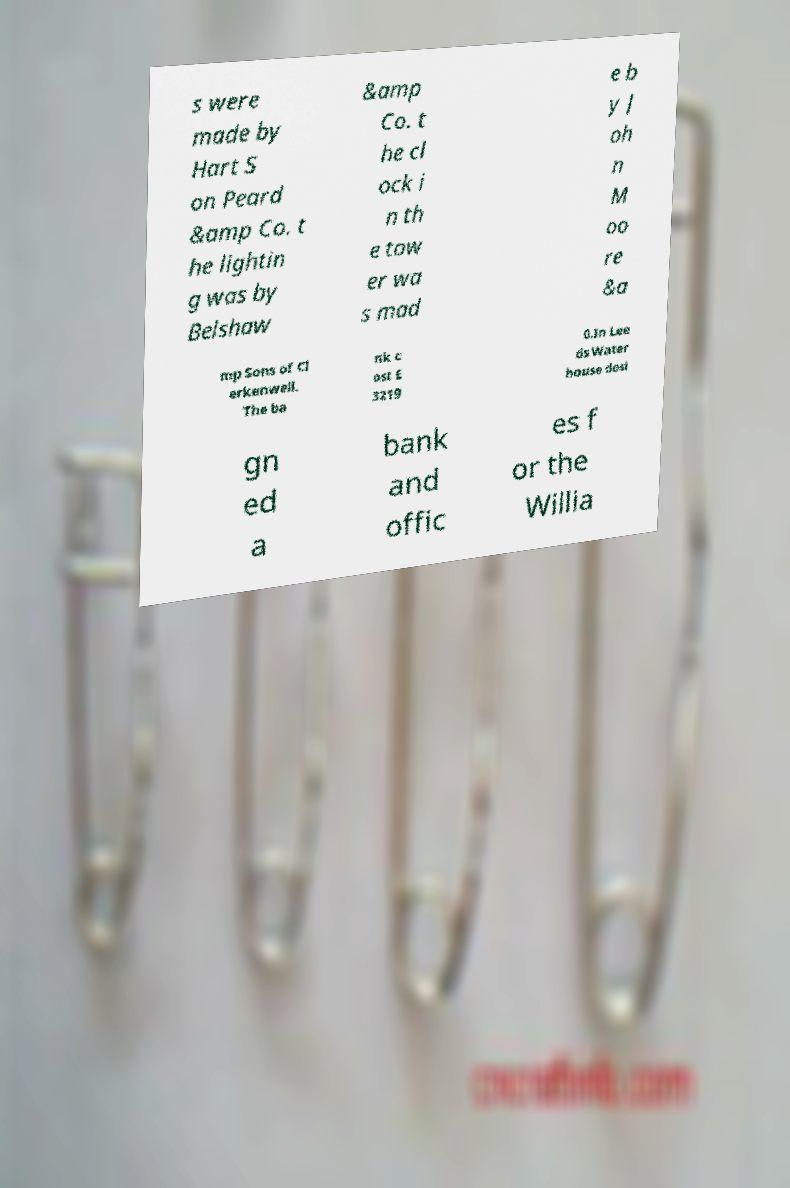Please identify and transcribe the text found in this image. s were made by Hart S on Peard &amp Co. t he lightin g was by Belshaw &amp Co. t he cl ock i n th e tow er wa s mad e b y J oh n M oo re &a mp Sons of Cl erkenwell. The ba nk c ost £ 3219 0.In Lee ds Water house desi gn ed a bank and offic es f or the Willia 